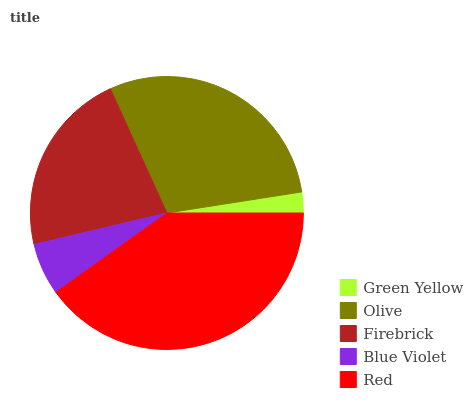Is Green Yellow the minimum?
Answer yes or no. Yes. Is Red the maximum?
Answer yes or no. Yes. Is Olive the minimum?
Answer yes or no. No. Is Olive the maximum?
Answer yes or no. No. Is Olive greater than Green Yellow?
Answer yes or no. Yes. Is Green Yellow less than Olive?
Answer yes or no. Yes. Is Green Yellow greater than Olive?
Answer yes or no. No. Is Olive less than Green Yellow?
Answer yes or no. No. Is Firebrick the high median?
Answer yes or no. Yes. Is Firebrick the low median?
Answer yes or no. Yes. Is Red the high median?
Answer yes or no. No. Is Olive the low median?
Answer yes or no. No. 